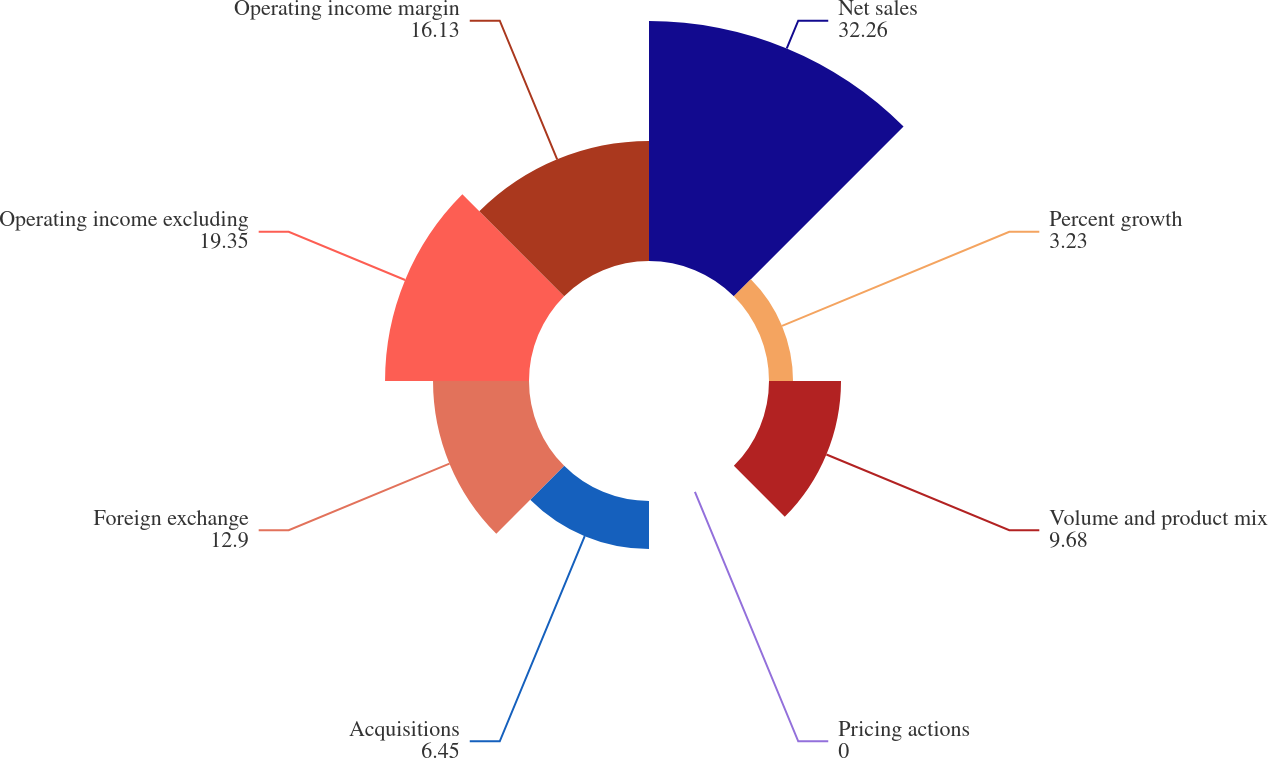<chart> <loc_0><loc_0><loc_500><loc_500><pie_chart><fcel>Net sales<fcel>Percent growth<fcel>Volume and product mix<fcel>Pricing actions<fcel>Acquisitions<fcel>Foreign exchange<fcel>Operating income excluding<fcel>Operating income margin<nl><fcel>32.26%<fcel>3.23%<fcel>9.68%<fcel>0.0%<fcel>6.45%<fcel>12.9%<fcel>19.35%<fcel>16.13%<nl></chart> 